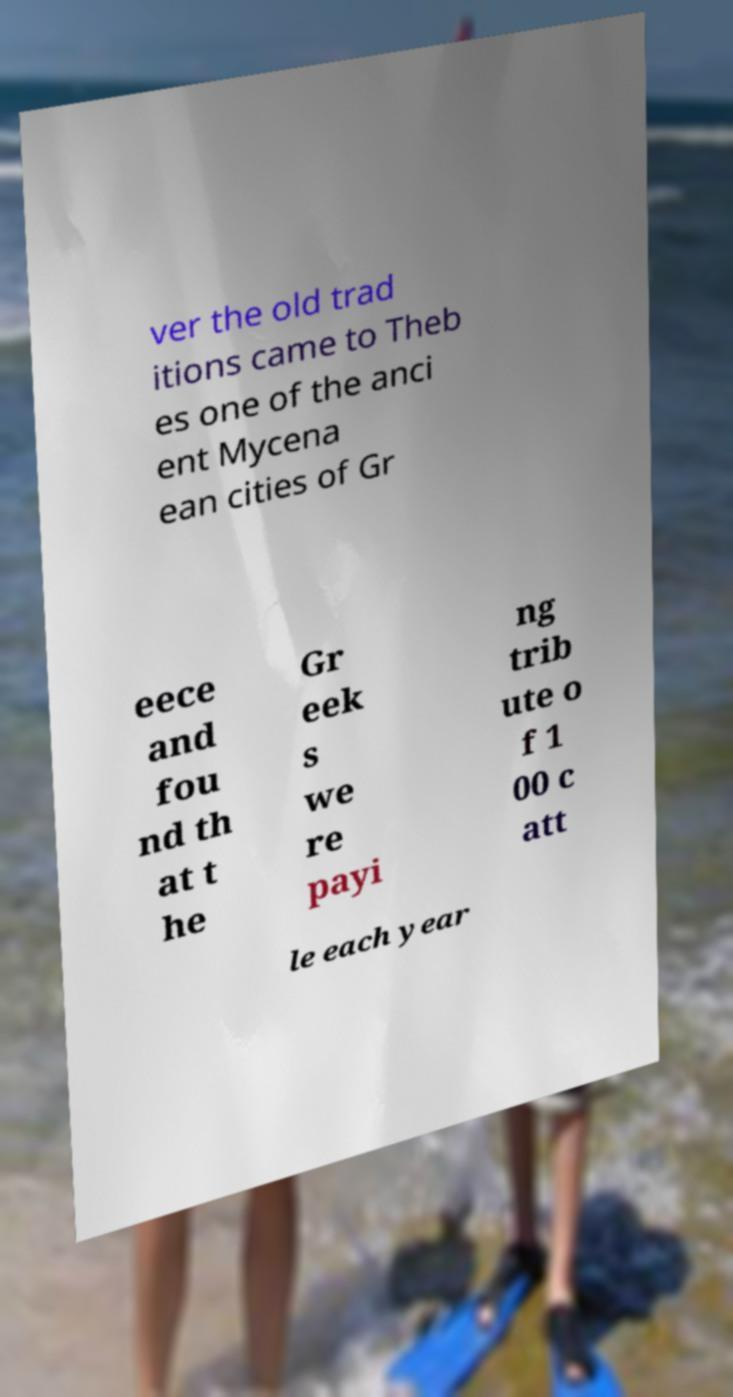Could you assist in decoding the text presented in this image and type it out clearly? ver the old trad itions came to Theb es one of the anci ent Mycena ean cities of Gr eece and fou nd th at t he Gr eek s we re payi ng trib ute o f 1 00 c att le each year 